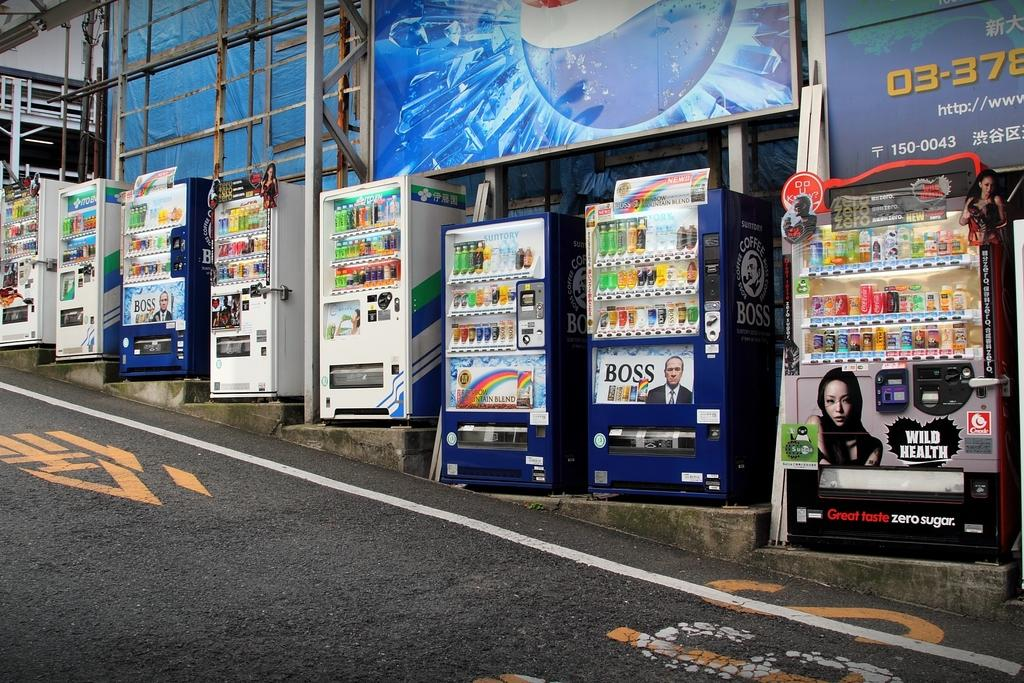<image>
Provide a brief description of the given image. Multiple vending machines on the side of street including the one that advertises BOSS coffee. 